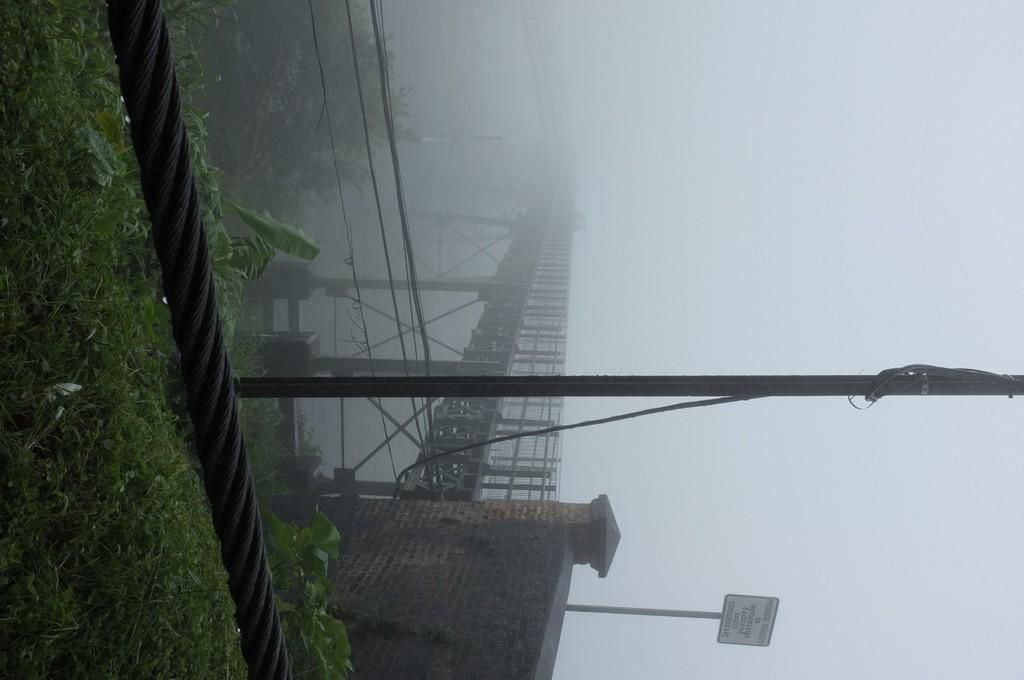What type of vegetation can be seen in the image? There is grass in the image. What objects can be seen in the image that are related to ropes or poles? There is a rope and a pole in the image. What type of structure is present in the image that allows people or objects to cross over something? There is a bridge in the image. What type of barrier or enclosure can be seen in the image? There is a wall in the image. What object in the image has text on it? There is a board in the image with text on it. What type of living organisms can be seen in the image besides grass? There are plants in the image. How would you describe the weather in the image based on the sky? The sky is foggy in the image. What type of butter can be seen melting on the board in the image? There is no butter present in the image; it only features a board with text on it. What type of thunder can be heard in the image? There is no sound present in the image, so it is not possible to determine if there is thunder or not. 